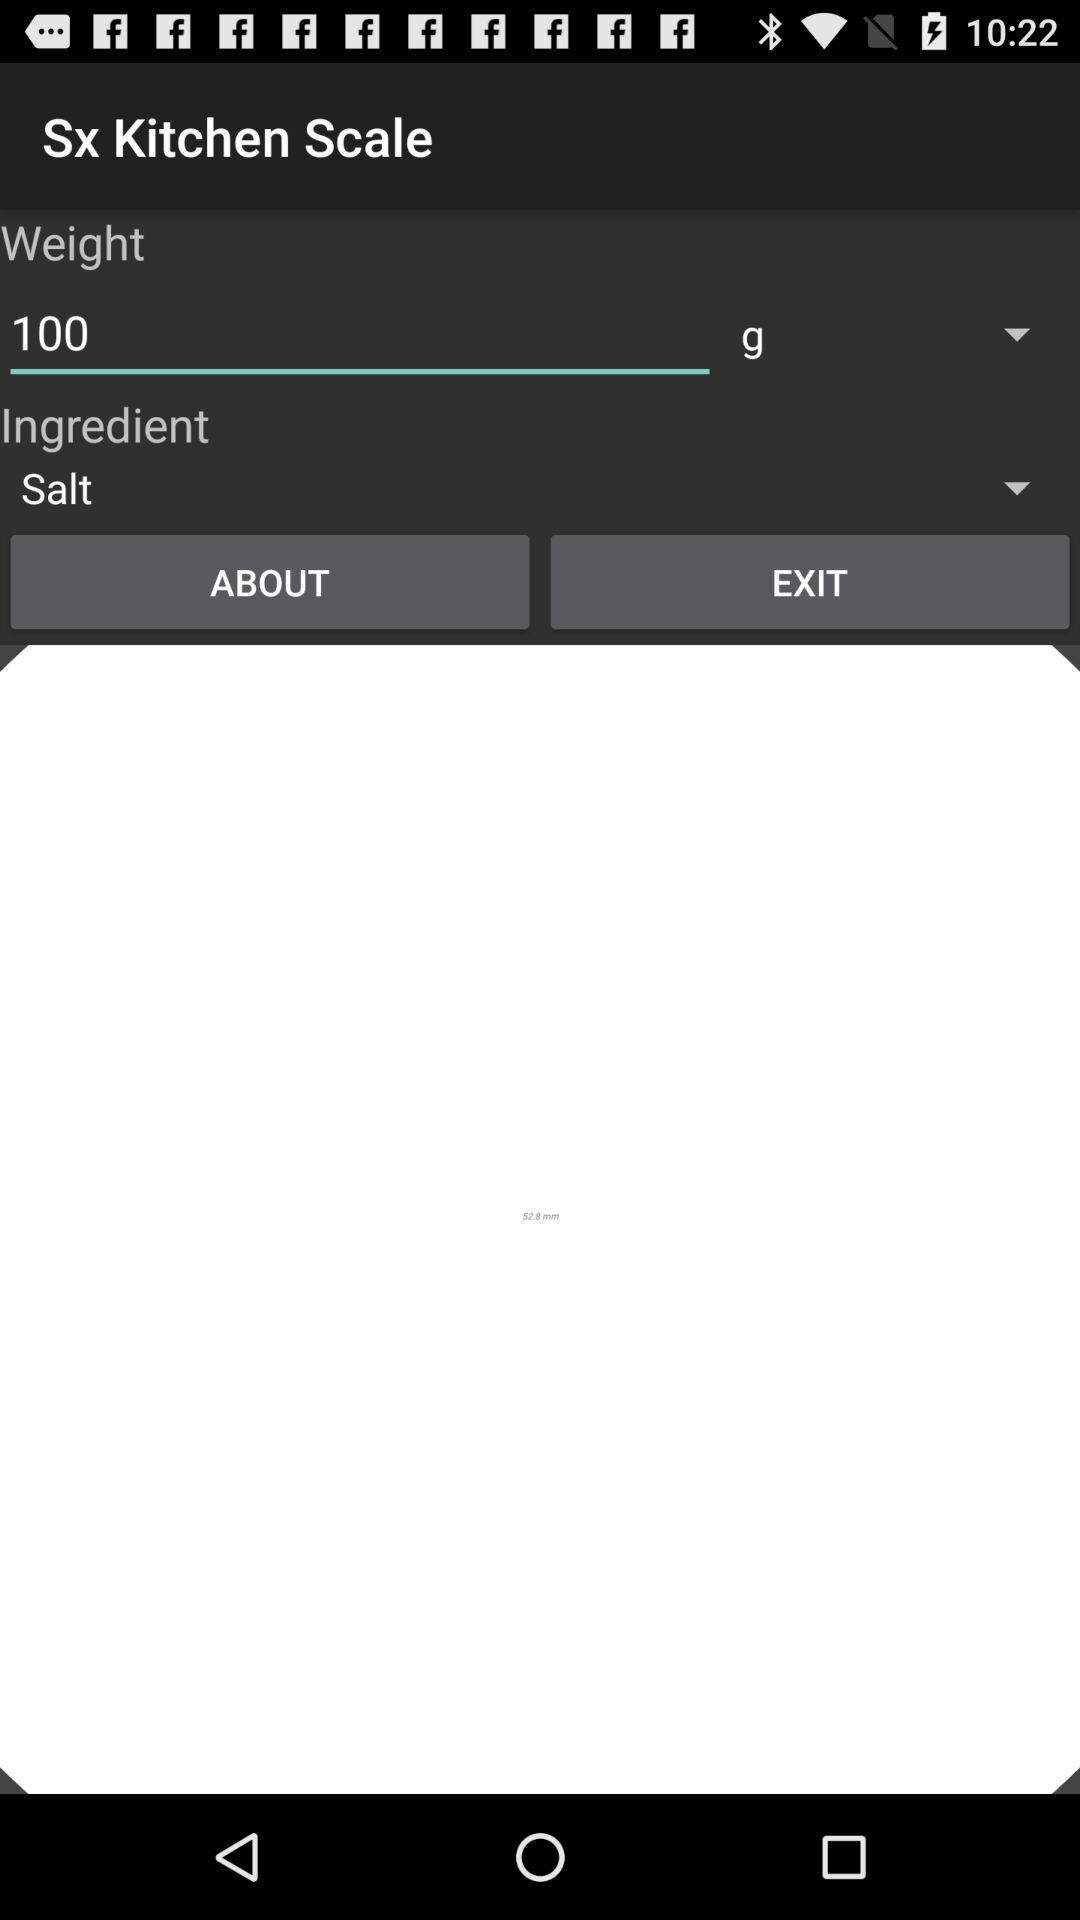What is the unit of weight? The unit of weight is gram. 